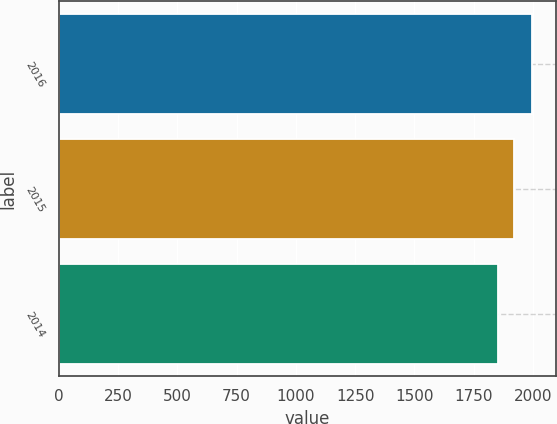Convert chart to OTSL. <chart><loc_0><loc_0><loc_500><loc_500><bar_chart><fcel>2016<fcel>2015<fcel>2014<nl><fcel>1997<fcel>1920<fcel>1855<nl></chart> 